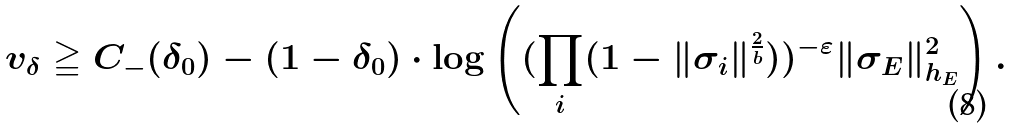Convert formula to latex. <formula><loc_0><loc_0><loc_500><loc_500>v _ { \delta } \geqq C _ { - } ( \delta _ { 0 } ) - ( 1 - \delta _ { 0 } ) \cdot \log \left ( ( \prod _ { i } ( 1 - \| \sigma _ { i } \| ^ { \frac { 2 } { b } } ) ) ^ { - \varepsilon } \| \sigma _ { E } \| _ { h _ { E } } ^ { 2 } \right ) .</formula> 